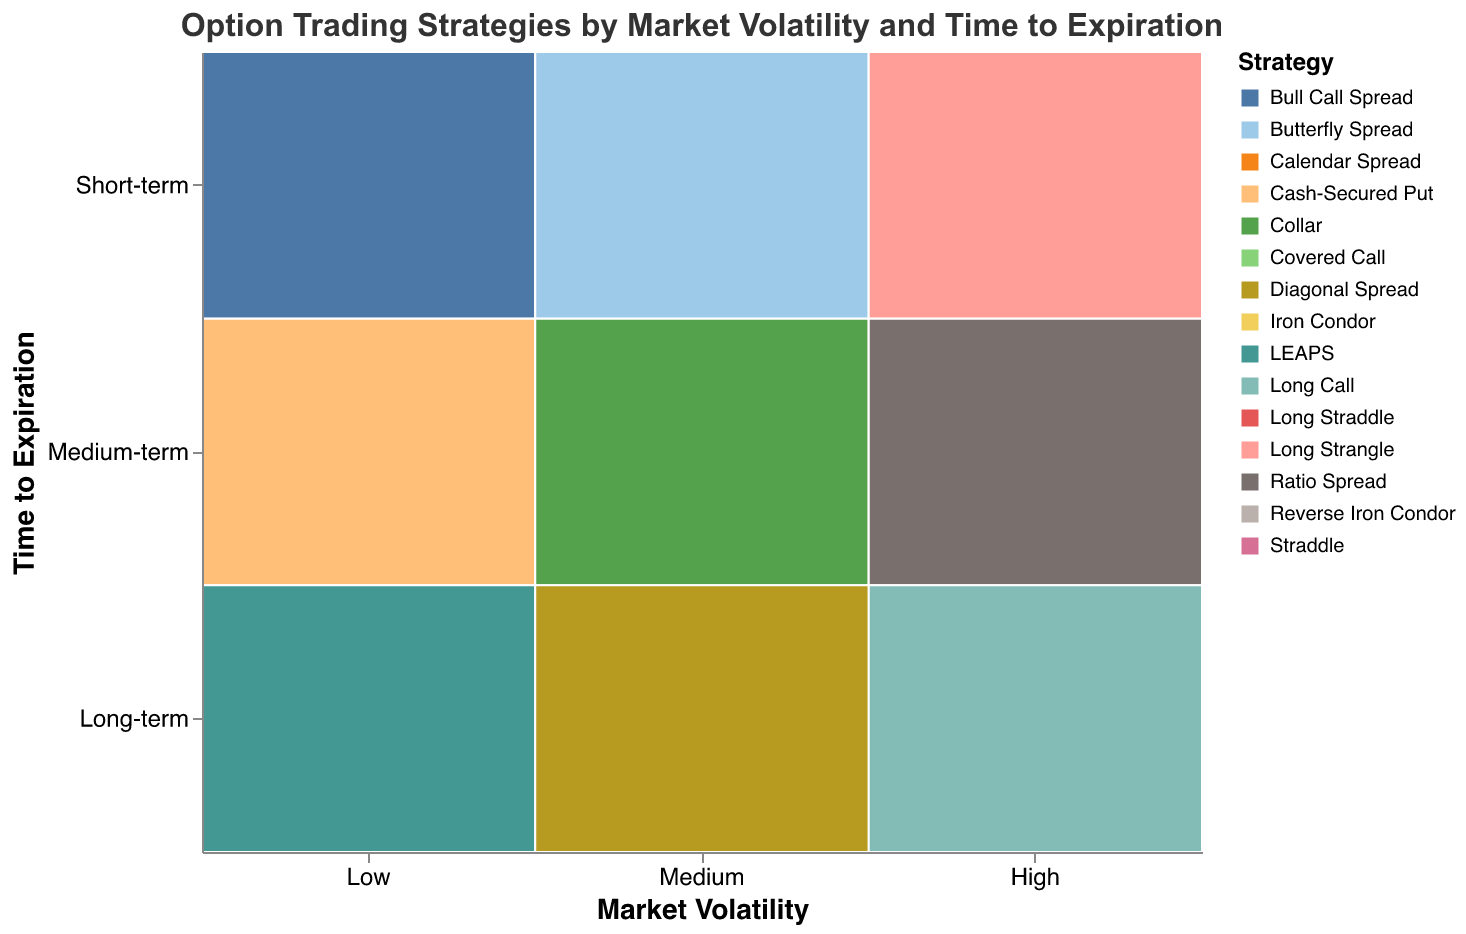What is the most frequently used strategy for Low market volatility and Medium-term expiration? Look at the block corresponding to Low market volatility and Medium-term expiration. The largest size rect is labeled "Iron Condor" with a frequency of 30.
Answer: Iron Condor How many strategies are there for High market volatility and Short-term expiration? Look at the blocks corresponding to High market volatility and Short-term expiration. There are two strategies: "Long Straddle" and "Long Strangle".
Answer: 2 Which strategy is most frequented across all market volatilities? Scan across all market volatilities to see which strategy has the highest frequency. The "Long Straddle" under High market volatility and Short-term expiration has the largest rectangle size or frequency (30).
Answer: Long Straddle What is the least used strategy for Low market volatility and Short-term expiration? Look at the blocks corresponding to Low market volatility and Short-term expiration. The smallest size rect is "Bull Call Spread" with a frequency of 15.
Answer: Bull Call Spread Compare the usage of LEAPS and Long Call strategies. Which is more frequent? Look at blocks for LEAPS under Low market volatility and Long-term expiration (frequency: 10) and Long Call under High market volatility and Long-term expiration (frequency: 10). They both have equal frequency.
Answer: Equal frequency Which market volatility has the highest diversity of strategies for Medium-term expiration? Compare the number of different strategies in the Medium-term expiration row for Low, Medium, and High market volatilities. Medium and High both have two strategies each, while Low has two.
Answer: Medium and High (equal) What strategy is used for Medium market volatility and Short-term expiration but not for Low market volatility and Medium-term expiration? Identify strategies under Medium market volatility and Short-term expiration (Straddle, Butterfly Spread). Neither of these is used under Low market volatility and Medium-term expiration. However, since "Straddle" appears only for Medium market volatility across all time frames, it's the answer.
Answer: Straddle What's the frequency difference between the most and least frequent strategies under High market volatility with Medium-term expiration? Look at the frequencies of strategies under High market volatility and Medium-term expiration, which are Reverse Iron Condor (20) and Ratio Spread (15). The difference is 20 - 15 = 5.
Answer: 5 